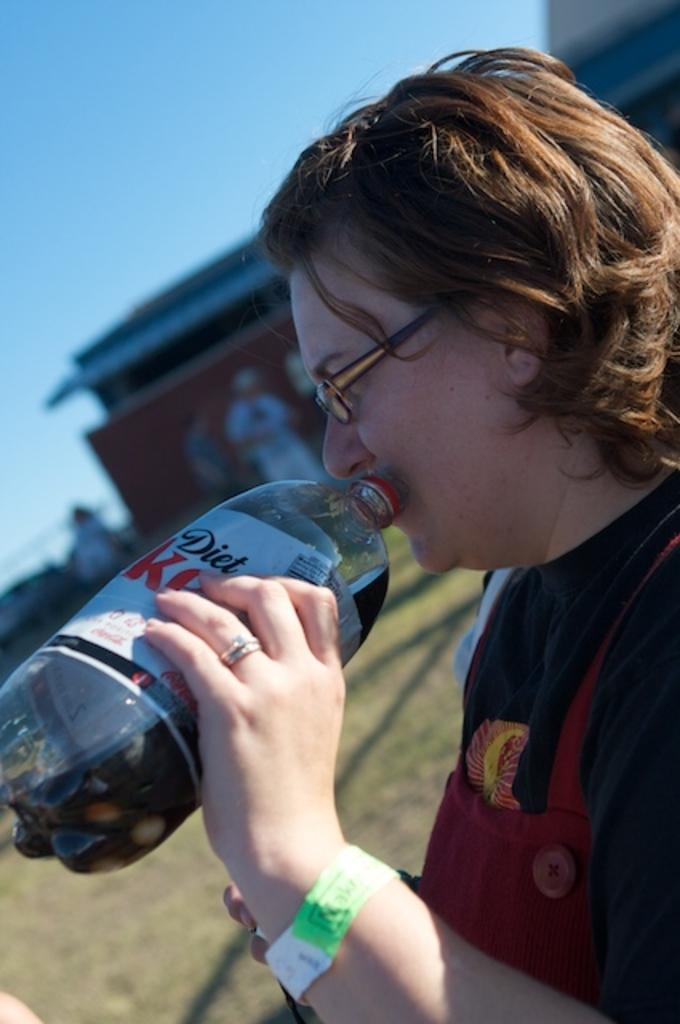What is the main subject of the image? There is a person in the image. What is the person holding in the image? The person is holding a bottle. What can be seen in the background of the image? There is a building and the sky visible in the background of the image. Can you tell me how many tigers are present in the image? There are no tigers present in the image; it features a person holding a bottle with a building and the sky in the background. Who is the creator of the building in the image? The creator of the building is not mentioned or visible in the image. 